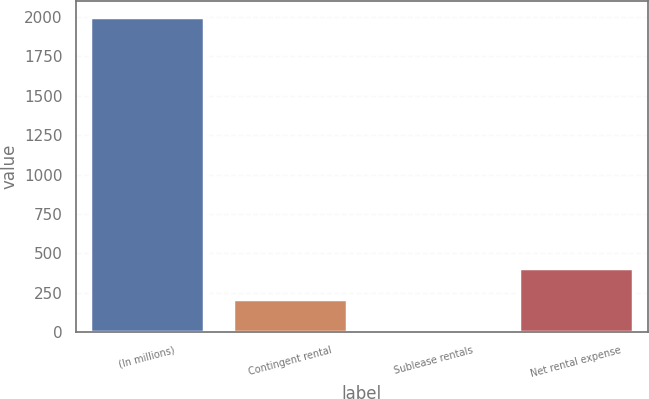Convert chart. <chart><loc_0><loc_0><loc_500><loc_500><bar_chart><fcel>(In millions)<fcel>Contingent rental<fcel>Sublease rentals<fcel>Net rental expense<nl><fcel>2002<fcel>210.1<fcel>11<fcel>409.2<nl></chart> 